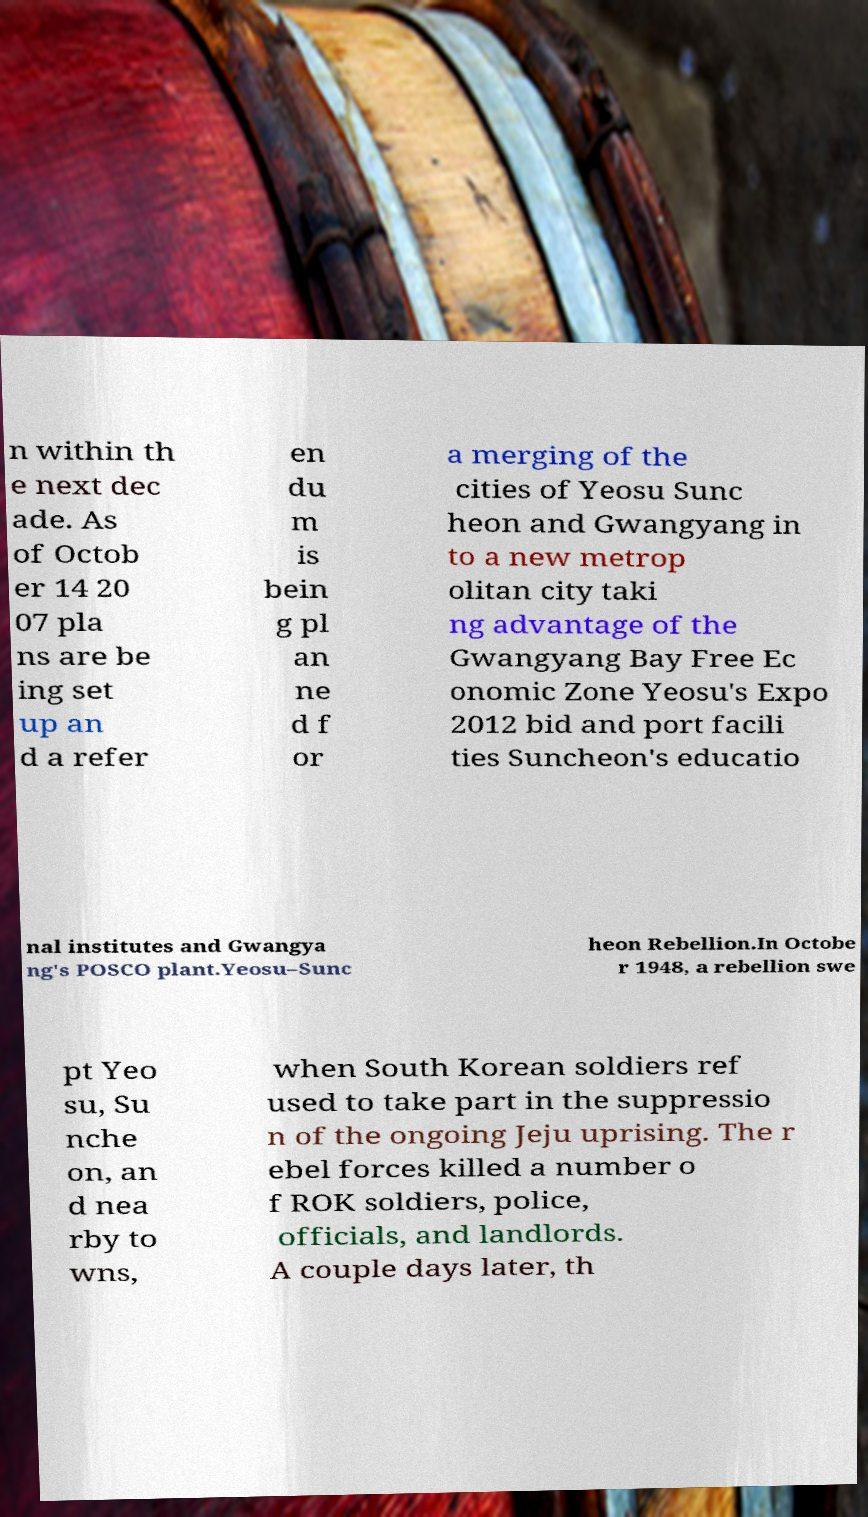Could you extract and type out the text from this image? n within th e next dec ade. As of Octob er 14 20 07 pla ns are be ing set up an d a refer en du m is bein g pl an ne d f or a merging of the cities of Yeosu Sunc heon and Gwangyang in to a new metrop olitan city taki ng advantage of the Gwangyang Bay Free Ec onomic Zone Yeosu's Expo 2012 bid and port facili ties Suncheon's educatio nal institutes and Gwangya ng's POSCO plant.Yeosu–Sunc heon Rebellion.In Octobe r 1948, a rebellion swe pt Yeo su, Su nche on, an d nea rby to wns, when South Korean soldiers ref used to take part in the suppressio n of the ongoing Jeju uprising. The r ebel forces killed a number o f ROK soldiers, police, officials, and landlords. A couple days later, th 